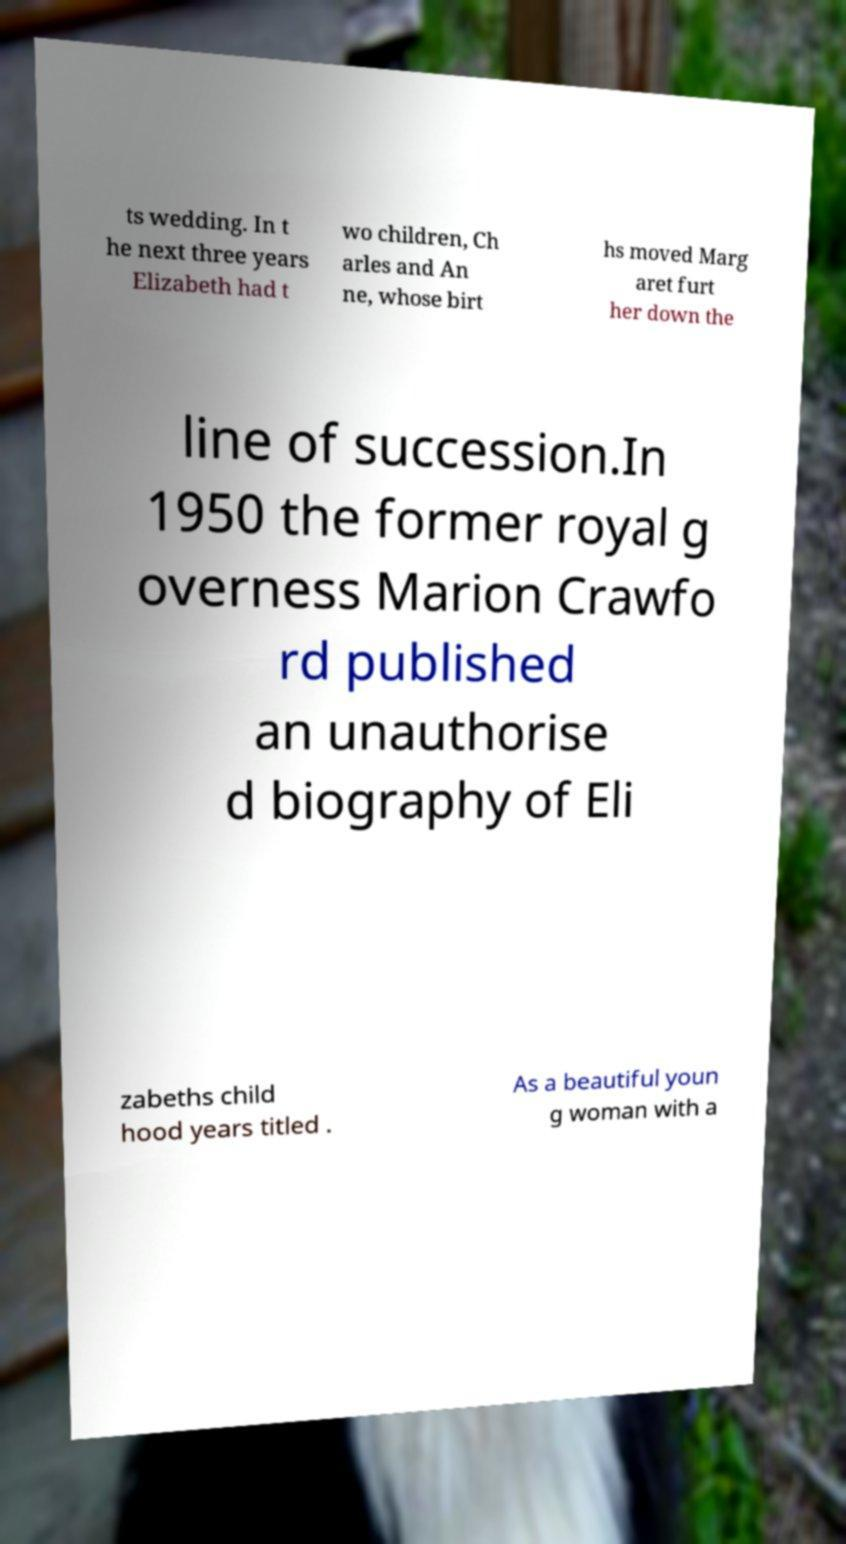Please read and relay the text visible in this image. What does it say? ts wedding. In t he next three years Elizabeth had t wo children, Ch arles and An ne, whose birt hs moved Marg aret furt her down the line of succession.In 1950 the former royal g overness Marion Crawfo rd published an unauthorise d biography of Eli zabeths child hood years titled . As a beautiful youn g woman with a 